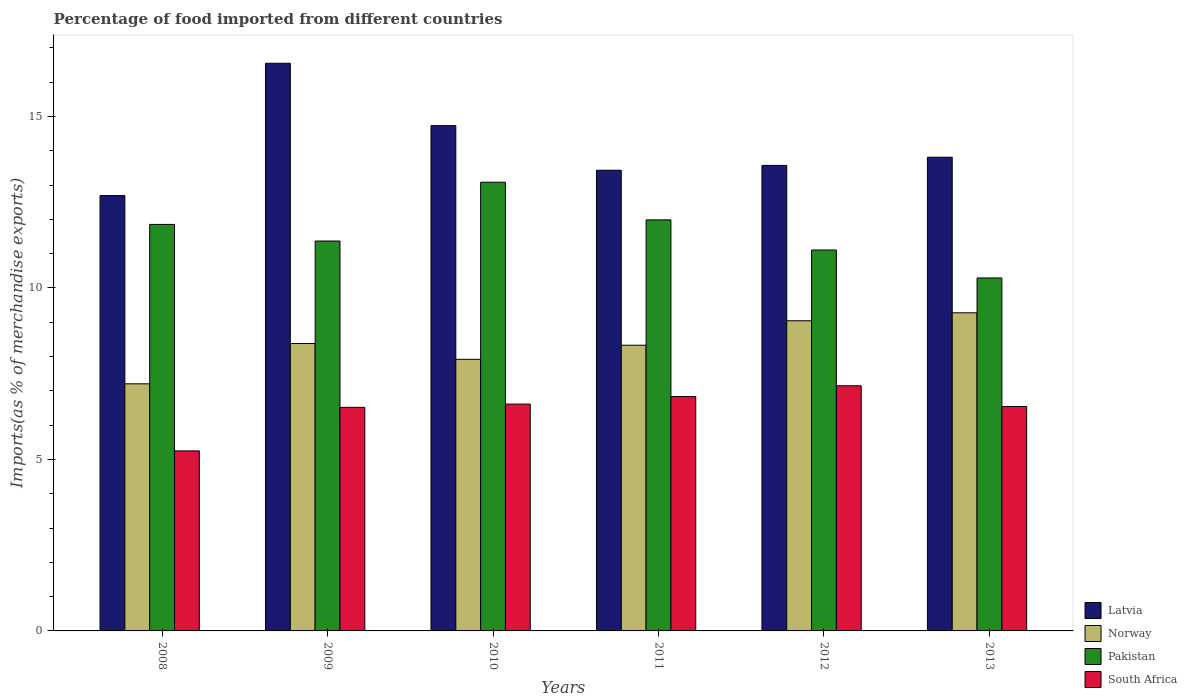How many different coloured bars are there?
Ensure brevity in your answer.  4. Are the number of bars per tick equal to the number of legend labels?
Your answer should be compact. Yes. How many bars are there on the 2nd tick from the left?
Provide a short and direct response. 4. How many bars are there on the 6th tick from the right?
Your response must be concise. 4. What is the label of the 2nd group of bars from the left?
Offer a terse response. 2009. What is the percentage of imports to different countries in Norway in 2008?
Your answer should be very brief. 7.21. Across all years, what is the maximum percentage of imports to different countries in Pakistan?
Provide a short and direct response. 13.08. Across all years, what is the minimum percentage of imports to different countries in Norway?
Offer a very short reply. 7.21. In which year was the percentage of imports to different countries in Norway minimum?
Offer a terse response. 2008. What is the total percentage of imports to different countries in South Africa in the graph?
Provide a succinct answer. 38.91. What is the difference between the percentage of imports to different countries in Pakistan in 2008 and that in 2013?
Your answer should be compact. 1.56. What is the difference between the percentage of imports to different countries in South Africa in 2010 and the percentage of imports to different countries in Norway in 2012?
Your answer should be very brief. -2.43. What is the average percentage of imports to different countries in Pakistan per year?
Make the answer very short. 11.62. In the year 2013, what is the difference between the percentage of imports to different countries in Pakistan and percentage of imports to different countries in Norway?
Your answer should be compact. 1.02. In how many years, is the percentage of imports to different countries in Norway greater than 1 %?
Your answer should be very brief. 6. What is the ratio of the percentage of imports to different countries in South Africa in 2011 to that in 2012?
Your answer should be very brief. 0.96. Is the difference between the percentage of imports to different countries in Pakistan in 2009 and 2011 greater than the difference between the percentage of imports to different countries in Norway in 2009 and 2011?
Your answer should be compact. No. What is the difference between the highest and the second highest percentage of imports to different countries in Latvia?
Keep it short and to the point. 1.82. What is the difference between the highest and the lowest percentage of imports to different countries in Norway?
Your answer should be compact. 2.07. Is it the case that in every year, the sum of the percentage of imports to different countries in Norway and percentage of imports to different countries in Pakistan is greater than the sum of percentage of imports to different countries in Latvia and percentage of imports to different countries in South Africa?
Make the answer very short. Yes. What does the 4th bar from the left in 2012 represents?
Keep it short and to the point. South Africa. What does the 1st bar from the right in 2011 represents?
Provide a short and direct response. South Africa. Is it the case that in every year, the sum of the percentage of imports to different countries in South Africa and percentage of imports to different countries in Latvia is greater than the percentage of imports to different countries in Pakistan?
Your answer should be compact. Yes. How many years are there in the graph?
Ensure brevity in your answer.  6. What is the difference between two consecutive major ticks on the Y-axis?
Offer a very short reply. 5. Does the graph contain any zero values?
Your answer should be very brief. No. How are the legend labels stacked?
Make the answer very short. Vertical. What is the title of the graph?
Your answer should be very brief. Percentage of food imported from different countries. What is the label or title of the X-axis?
Your response must be concise. Years. What is the label or title of the Y-axis?
Provide a short and direct response. Imports(as % of merchandise exports). What is the Imports(as % of merchandise exports) of Latvia in 2008?
Give a very brief answer. 12.69. What is the Imports(as % of merchandise exports) of Norway in 2008?
Your answer should be compact. 7.21. What is the Imports(as % of merchandise exports) in Pakistan in 2008?
Provide a succinct answer. 11.85. What is the Imports(as % of merchandise exports) of South Africa in 2008?
Provide a short and direct response. 5.25. What is the Imports(as % of merchandise exports) in Latvia in 2009?
Your answer should be compact. 16.55. What is the Imports(as % of merchandise exports) of Norway in 2009?
Offer a very short reply. 8.38. What is the Imports(as % of merchandise exports) in Pakistan in 2009?
Give a very brief answer. 11.37. What is the Imports(as % of merchandise exports) of South Africa in 2009?
Provide a short and direct response. 6.52. What is the Imports(as % of merchandise exports) of Latvia in 2010?
Your answer should be compact. 14.73. What is the Imports(as % of merchandise exports) of Norway in 2010?
Give a very brief answer. 7.92. What is the Imports(as % of merchandise exports) of Pakistan in 2010?
Offer a very short reply. 13.08. What is the Imports(as % of merchandise exports) of South Africa in 2010?
Offer a very short reply. 6.61. What is the Imports(as % of merchandise exports) of Latvia in 2011?
Make the answer very short. 13.43. What is the Imports(as % of merchandise exports) of Norway in 2011?
Your answer should be compact. 8.33. What is the Imports(as % of merchandise exports) of Pakistan in 2011?
Give a very brief answer. 11.99. What is the Imports(as % of merchandise exports) of South Africa in 2011?
Your answer should be very brief. 6.83. What is the Imports(as % of merchandise exports) in Latvia in 2012?
Your answer should be very brief. 13.57. What is the Imports(as % of merchandise exports) of Norway in 2012?
Your answer should be compact. 9.04. What is the Imports(as % of merchandise exports) of Pakistan in 2012?
Make the answer very short. 11.11. What is the Imports(as % of merchandise exports) of South Africa in 2012?
Offer a very short reply. 7.15. What is the Imports(as % of merchandise exports) of Latvia in 2013?
Provide a short and direct response. 13.81. What is the Imports(as % of merchandise exports) in Norway in 2013?
Provide a short and direct response. 9.28. What is the Imports(as % of merchandise exports) in Pakistan in 2013?
Keep it short and to the point. 10.29. What is the Imports(as % of merchandise exports) in South Africa in 2013?
Provide a succinct answer. 6.54. Across all years, what is the maximum Imports(as % of merchandise exports) in Latvia?
Provide a succinct answer. 16.55. Across all years, what is the maximum Imports(as % of merchandise exports) in Norway?
Offer a very short reply. 9.28. Across all years, what is the maximum Imports(as % of merchandise exports) in Pakistan?
Your response must be concise. 13.08. Across all years, what is the maximum Imports(as % of merchandise exports) of South Africa?
Your answer should be compact. 7.15. Across all years, what is the minimum Imports(as % of merchandise exports) of Latvia?
Give a very brief answer. 12.69. Across all years, what is the minimum Imports(as % of merchandise exports) in Norway?
Your response must be concise. 7.21. Across all years, what is the minimum Imports(as % of merchandise exports) of Pakistan?
Offer a terse response. 10.29. Across all years, what is the minimum Imports(as % of merchandise exports) of South Africa?
Keep it short and to the point. 5.25. What is the total Imports(as % of merchandise exports) of Latvia in the graph?
Your answer should be very brief. 84.8. What is the total Imports(as % of merchandise exports) of Norway in the graph?
Keep it short and to the point. 50.16. What is the total Imports(as % of merchandise exports) of Pakistan in the graph?
Keep it short and to the point. 69.69. What is the total Imports(as % of merchandise exports) in South Africa in the graph?
Ensure brevity in your answer.  38.91. What is the difference between the Imports(as % of merchandise exports) in Latvia in 2008 and that in 2009?
Make the answer very short. -3.86. What is the difference between the Imports(as % of merchandise exports) of Norway in 2008 and that in 2009?
Provide a succinct answer. -1.18. What is the difference between the Imports(as % of merchandise exports) of Pakistan in 2008 and that in 2009?
Ensure brevity in your answer.  0.48. What is the difference between the Imports(as % of merchandise exports) in South Africa in 2008 and that in 2009?
Offer a very short reply. -1.27. What is the difference between the Imports(as % of merchandise exports) in Latvia in 2008 and that in 2010?
Your answer should be very brief. -2.04. What is the difference between the Imports(as % of merchandise exports) of Norway in 2008 and that in 2010?
Keep it short and to the point. -0.71. What is the difference between the Imports(as % of merchandise exports) in Pakistan in 2008 and that in 2010?
Make the answer very short. -1.23. What is the difference between the Imports(as % of merchandise exports) of South Africa in 2008 and that in 2010?
Your response must be concise. -1.36. What is the difference between the Imports(as % of merchandise exports) in Latvia in 2008 and that in 2011?
Provide a succinct answer. -0.74. What is the difference between the Imports(as % of merchandise exports) of Norway in 2008 and that in 2011?
Ensure brevity in your answer.  -1.13. What is the difference between the Imports(as % of merchandise exports) of Pakistan in 2008 and that in 2011?
Your answer should be very brief. -0.13. What is the difference between the Imports(as % of merchandise exports) of South Africa in 2008 and that in 2011?
Your answer should be very brief. -1.58. What is the difference between the Imports(as % of merchandise exports) of Latvia in 2008 and that in 2012?
Offer a terse response. -0.88. What is the difference between the Imports(as % of merchandise exports) of Norway in 2008 and that in 2012?
Give a very brief answer. -1.84. What is the difference between the Imports(as % of merchandise exports) of Pakistan in 2008 and that in 2012?
Provide a succinct answer. 0.75. What is the difference between the Imports(as % of merchandise exports) in South Africa in 2008 and that in 2012?
Provide a succinct answer. -1.9. What is the difference between the Imports(as % of merchandise exports) in Latvia in 2008 and that in 2013?
Offer a terse response. -1.12. What is the difference between the Imports(as % of merchandise exports) in Norway in 2008 and that in 2013?
Keep it short and to the point. -2.07. What is the difference between the Imports(as % of merchandise exports) of Pakistan in 2008 and that in 2013?
Offer a terse response. 1.56. What is the difference between the Imports(as % of merchandise exports) of South Africa in 2008 and that in 2013?
Ensure brevity in your answer.  -1.29. What is the difference between the Imports(as % of merchandise exports) in Latvia in 2009 and that in 2010?
Ensure brevity in your answer.  1.82. What is the difference between the Imports(as % of merchandise exports) in Norway in 2009 and that in 2010?
Ensure brevity in your answer.  0.46. What is the difference between the Imports(as % of merchandise exports) in Pakistan in 2009 and that in 2010?
Your answer should be very brief. -1.71. What is the difference between the Imports(as % of merchandise exports) of South Africa in 2009 and that in 2010?
Your response must be concise. -0.1. What is the difference between the Imports(as % of merchandise exports) in Latvia in 2009 and that in 2011?
Your answer should be compact. 3.12. What is the difference between the Imports(as % of merchandise exports) in Norway in 2009 and that in 2011?
Your answer should be very brief. 0.05. What is the difference between the Imports(as % of merchandise exports) in Pakistan in 2009 and that in 2011?
Your answer should be compact. -0.62. What is the difference between the Imports(as % of merchandise exports) in South Africa in 2009 and that in 2011?
Ensure brevity in your answer.  -0.32. What is the difference between the Imports(as % of merchandise exports) of Latvia in 2009 and that in 2012?
Your answer should be very brief. 2.98. What is the difference between the Imports(as % of merchandise exports) in Norway in 2009 and that in 2012?
Your answer should be compact. -0.66. What is the difference between the Imports(as % of merchandise exports) in Pakistan in 2009 and that in 2012?
Keep it short and to the point. 0.26. What is the difference between the Imports(as % of merchandise exports) in South Africa in 2009 and that in 2012?
Offer a terse response. -0.63. What is the difference between the Imports(as % of merchandise exports) of Latvia in 2009 and that in 2013?
Your response must be concise. 2.74. What is the difference between the Imports(as % of merchandise exports) in Norway in 2009 and that in 2013?
Your answer should be very brief. -0.9. What is the difference between the Imports(as % of merchandise exports) of Pakistan in 2009 and that in 2013?
Keep it short and to the point. 1.08. What is the difference between the Imports(as % of merchandise exports) in South Africa in 2009 and that in 2013?
Provide a succinct answer. -0.02. What is the difference between the Imports(as % of merchandise exports) of Latvia in 2010 and that in 2011?
Give a very brief answer. 1.3. What is the difference between the Imports(as % of merchandise exports) of Norway in 2010 and that in 2011?
Your answer should be very brief. -0.41. What is the difference between the Imports(as % of merchandise exports) in Pakistan in 2010 and that in 2011?
Offer a terse response. 1.1. What is the difference between the Imports(as % of merchandise exports) in South Africa in 2010 and that in 2011?
Provide a succinct answer. -0.22. What is the difference between the Imports(as % of merchandise exports) of Latvia in 2010 and that in 2012?
Make the answer very short. 1.16. What is the difference between the Imports(as % of merchandise exports) of Norway in 2010 and that in 2012?
Make the answer very short. -1.12. What is the difference between the Imports(as % of merchandise exports) in Pakistan in 2010 and that in 2012?
Keep it short and to the point. 1.98. What is the difference between the Imports(as % of merchandise exports) of South Africa in 2010 and that in 2012?
Give a very brief answer. -0.53. What is the difference between the Imports(as % of merchandise exports) in Latvia in 2010 and that in 2013?
Your answer should be compact. 0.92. What is the difference between the Imports(as % of merchandise exports) of Norway in 2010 and that in 2013?
Ensure brevity in your answer.  -1.36. What is the difference between the Imports(as % of merchandise exports) of Pakistan in 2010 and that in 2013?
Offer a terse response. 2.79. What is the difference between the Imports(as % of merchandise exports) in South Africa in 2010 and that in 2013?
Provide a succinct answer. 0.07. What is the difference between the Imports(as % of merchandise exports) in Latvia in 2011 and that in 2012?
Your answer should be very brief. -0.14. What is the difference between the Imports(as % of merchandise exports) of Norway in 2011 and that in 2012?
Keep it short and to the point. -0.71. What is the difference between the Imports(as % of merchandise exports) in Pakistan in 2011 and that in 2012?
Offer a very short reply. 0.88. What is the difference between the Imports(as % of merchandise exports) of South Africa in 2011 and that in 2012?
Make the answer very short. -0.31. What is the difference between the Imports(as % of merchandise exports) in Latvia in 2011 and that in 2013?
Provide a short and direct response. -0.38. What is the difference between the Imports(as % of merchandise exports) of Norway in 2011 and that in 2013?
Your response must be concise. -0.95. What is the difference between the Imports(as % of merchandise exports) in Pakistan in 2011 and that in 2013?
Keep it short and to the point. 1.69. What is the difference between the Imports(as % of merchandise exports) in South Africa in 2011 and that in 2013?
Give a very brief answer. 0.29. What is the difference between the Imports(as % of merchandise exports) in Latvia in 2012 and that in 2013?
Offer a very short reply. -0.24. What is the difference between the Imports(as % of merchandise exports) in Norway in 2012 and that in 2013?
Your answer should be compact. -0.23. What is the difference between the Imports(as % of merchandise exports) in Pakistan in 2012 and that in 2013?
Keep it short and to the point. 0.82. What is the difference between the Imports(as % of merchandise exports) in South Africa in 2012 and that in 2013?
Provide a short and direct response. 0.6. What is the difference between the Imports(as % of merchandise exports) of Latvia in 2008 and the Imports(as % of merchandise exports) of Norway in 2009?
Provide a succinct answer. 4.31. What is the difference between the Imports(as % of merchandise exports) in Latvia in 2008 and the Imports(as % of merchandise exports) in Pakistan in 2009?
Make the answer very short. 1.32. What is the difference between the Imports(as % of merchandise exports) of Latvia in 2008 and the Imports(as % of merchandise exports) of South Africa in 2009?
Offer a very short reply. 6.18. What is the difference between the Imports(as % of merchandise exports) in Norway in 2008 and the Imports(as % of merchandise exports) in Pakistan in 2009?
Provide a short and direct response. -4.16. What is the difference between the Imports(as % of merchandise exports) of Norway in 2008 and the Imports(as % of merchandise exports) of South Africa in 2009?
Your response must be concise. 0.69. What is the difference between the Imports(as % of merchandise exports) in Pakistan in 2008 and the Imports(as % of merchandise exports) in South Africa in 2009?
Offer a very short reply. 5.33. What is the difference between the Imports(as % of merchandise exports) of Latvia in 2008 and the Imports(as % of merchandise exports) of Norway in 2010?
Your response must be concise. 4.77. What is the difference between the Imports(as % of merchandise exports) in Latvia in 2008 and the Imports(as % of merchandise exports) in Pakistan in 2010?
Offer a very short reply. -0.39. What is the difference between the Imports(as % of merchandise exports) in Latvia in 2008 and the Imports(as % of merchandise exports) in South Africa in 2010?
Your answer should be compact. 6.08. What is the difference between the Imports(as % of merchandise exports) in Norway in 2008 and the Imports(as % of merchandise exports) in Pakistan in 2010?
Offer a very short reply. -5.88. What is the difference between the Imports(as % of merchandise exports) in Norway in 2008 and the Imports(as % of merchandise exports) in South Africa in 2010?
Ensure brevity in your answer.  0.59. What is the difference between the Imports(as % of merchandise exports) of Pakistan in 2008 and the Imports(as % of merchandise exports) of South Africa in 2010?
Offer a terse response. 5.24. What is the difference between the Imports(as % of merchandise exports) in Latvia in 2008 and the Imports(as % of merchandise exports) in Norway in 2011?
Offer a terse response. 4.36. What is the difference between the Imports(as % of merchandise exports) in Latvia in 2008 and the Imports(as % of merchandise exports) in Pakistan in 2011?
Your response must be concise. 0.71. What is the difference between the Imports(as % of merchandise exports) of Latvia in 2008 and the Imports(as % of merchandise exports) of South Africa in 2011?
Provide a short and direct response. 5.86. What is the difference between the Imports(as % of merchandise exports) of Norway in 2008 and the Imports(as % of merchandise exports) of Pakistan in 2011?
Offer a very short reply. -4.78. What is the difference between the Imports(as % of merchandise exports) in Norway in 2008 and the Imports(as % of merchandise exports) in South Africa in 2011?
Your response must be concise. 0.37. What is the difference between the Imports(as % of merchandise exports) in Pakistan in 2008 and the Imports(as % of merchandise exports) in South Africa in 2011?
Your answer should be very brief. 5.02. What is the difference between the Imports(as % of merchandise exports) of Latvia in 2008 and the Imports(as % of merchandise exports) of Norway in 2012?
Make the answer very short. 3.65. What is the difference between the Imports(as % of merchandise exports) of Latvia in 2008 and the Imports(as % of merchandise exports) of Pakistan in 2012?
Ensure brevity in your answer.  1.59. What is the difference between the Imports(as % of merchandise exports) in Latvia in 2008 and the Imports(as % of merchandise exports) in South Africa in 2012?
Provide a short and direct response. 5.55. What is the difference between the Imports(as % of merchandise exports) of Norway in 2008 and the Imports(as % of merchandise exports) of Pakistan in 2012?
Offer a very short reply. -3.9. What is the difference between the Imports(as % of merchandise exports) in Norway in 2008 and the Imports(as % of merchandise exports) in South Africa in 2012?
Your answer should be very brief. 0.06. What is the difference between the Imports(as % of merchandise exports) of Pakistan in 2008 and the Imports(as % of merchandise exports) of South Africa in 2012?
Make the answer very short. 4.71. What is the difference between the Imports(as % of merchandise exports) of Latvia in 2008 and the Imports(as % of merchandise exports) of Norway in 2013?
Your answer should be compact. 3.42. What is the difference between the Imports(as % of merchandise exports) in Latvia in 2008 and the Imports(as % of merchandise exports) in Pakistan in 2013?
Your answer should be compact. 2.4. What is the difference between the Imports(as % of merchandise exports) in Latvia in 2008 and the Imports(as % of merchandise exports) in South Africa in 2013?
Keep it short and to the point. 6.15. What is the difference between the Imports(as % of merchandise exports) of Norway in 2008 and the Imports(as % of merchandise exports) of Pakistan in 2013?
Ensure brevity in your answer.  -3.09. What is the difference between the Imports(as % of merchandise exports) of Norway in 2008 and the Imports(as % of merchandise exports) of South Africa in 2013?
Ensure brevity in your answer.  0.66. What is the difference between the Imports(as % of merchandise exports) in Pakistan in 2008 and the Imports(as % of merchandise exports) in South Africa in 2013?
Provide a succinct answer. 5.31. What is the difference between the Imports(as % of merchandise exports) of Latvia in 2009 and the Imports(as % of merchandise exports) of Norway in 2010?
Your answer should be compact. 8.63. What is the difference between the Imports(as % of merchandise exports) in Latvia in 2009 and the Imports(as % of merchandise exports) in Pakistan in 2010?
Give a very brief answer. 3.47. What is the difference between the Imports(as % of merchandise exports) of Latvia in 2009 and the Imports(as % of merchandise exports) of South Africa in 2010?
Give a very brief answer. 9.94. What is the difference between the Imports(as % of merchandise exports) in Norway in 2009 and the Imports(as % of merchandise exports) in Pakistan in 2010?
Provide a short and direct response. -4.7. What is the difference between the Imports(as % of merchandise exports) of Norway in 2009 and the Imports(as % of merchandise exports) of South Africa in 2010?
Provide a short and direct response. 1.77. What is the difference between the Imports(as % of merchandise exports) of Pakistan in 2009 and the Imports(as % of merchandise exports) of South Africa in 2010?
Your answer should be compact. 4.75. What is the difference between the Imports(as % of merchandise exports) in Latvia in 2009 and the Imports(as % of merchandise exports) in Norway in 2011?
Provide a succinct answer. 8.22. What is the difference between the Imports(as % of merchandise exports) in Latvia in 2009 and the Imports(as % of merchandise exports) in Pakistan in 2011?
Offer a terse response. 4.57. What is the difference between the Imports(as % of merchandise exports) of Latvia in 2009 and the Imports(as % of merchandise exports) of South Africa in 2011?
Provide a succinct answer. 9.72. What is the difference between the Imports(as % of merchandise exports) in Norway in 2009 and the Imports(as % of merchandise exports) in Pakistan in 2011?
Keep it short and to the point. -3.61. What is the difference between the Imports(as % of merchandise exports) in Norway in 2009 and the Imports(as % of merchandise exports) in South Africa in 2011?
Provide a short and direct response. 1.55. What is the difference between the Imports(as % of merchandise exports) in Pakistan in 2009 and the Imports(as % of merchandise exports) in South Africa in 2011?
Ensure brevity in your answer.  4.54. What is the difference between the Imports(as % of merchandise exports) in Latvia in 2009 and the Imports(as % of merchandise exports) in Norway in 2012?
Provide a succinct answer. 7.51. What is the difference between the Imports(as % of merchandise exports) of Latvia in 2009 and the Imports(as % of merchandise exports) of Pakistan in 2012?
Make the answer very short. 5.45. What is the difference between the Imports(as % of merchandise exports) in Latvia in 2009 and the Imports(as % of merchandise exports) in South Africa in 2012?
Provide a short and direct response. 9.4. What is the difference between the Imports(as % of merchandise exports) in Norway in 2009 and the Imports(as % of merchandise exports) in Pakistan in 2012?
Your answer should be very brief. -2.73. What is the difference between the Imports(as % of merchandise exports) of Norway in 2009 and the Imports(as % of merchandise exports) of South Africa in 2012?
Keep it short and to the point. 1.23. What is the difference between the Imports(as % of merchandise exports) of Pakistan in 2009 and the Imports(as % of merchandise exports) of South Africa in 2012?
Offer a terse response. 4.22. What is the difference between the Imports(as % of merchandise exports) of Latvia in 2009 and the Imports(as % of merchandise exports) of Norway in 2013?
Ensure brevity in your answer.  7.28. What is the difference between the Imports(as % of merchandise exports) of Latvia in 2009 and the Imports(as % of merchandise exports) of Pakistan in 2013?
Provide a short and direct response. 6.26. What is the difference between the Imports(as % of merchandise exports) of Latvia in 2009 and the Imports(as % of merchandise exports) of South Africa in 2013?
Give a very brief answer. 10.01. What is the difference between the Imports(as % of merchandise exports) in Norway in 2009 and the Imports(as % of merchandise exports) in Pakistan in 2013?
Offer a terse response. -1.91. What is the difference between the Imports(as % of merchandise exports) of Norway in 2009 and the Imports(as % of merchandise exports) of South Africa in 2013?
Your answer should be compact. 1.84. What is the difference between the Imports(as % of merchandise exports) in Pakistan in 2009 and the Imports(as % of merchandise exports) in South Africa in 2013?
Provide a succinct answer. 4.83. What is the difference between the Imports(as % of merchandise exports) in Latvia in 2010 and the Imports(as % of merchandise exports) in Norway in 2011?
Your answer should be compact. 6.4. What is the difference between the Imports(as % of merchandise exports) of Latvia in 2010 and the Imports(as % of merchandise exports) of Pakistan in 2011?
Give a very brief answer. 2.75. What is the difference between the Imports(as % of merchandise exports) in Latvia in 2010 and the Imports(as % of merchandise exports) in South Africa in 2011?
Your response must be concise. 7.9. What is the difference between the Imports(as % of merchandise exports) in Norway in 2010 and the Imports(as % of merchandise exports) in Pakistan in 2011?
Ensure brevity in your answer.  -4.07. What is the difference between the Imports(as % of merchandise exports) of Norway in 2010 and the Imports(as % of merchandise exports) of South Africa in 2011?
Provide a succinct answer. 1.09. What is the difference between the Imports(as % of merchandise exports) of Pakistan in 2010 and the Imports(as % of merchandise exports) of South Africa in 2011?
Keep it short and to the point. 6.25. What is the difference between the Imports(as % of merchandise exports) in Latvia in 2010 and the Imports(as % of merchandise exports) in Norway in 2012?
Provide a short and direct response. 5.69. What is the difference between the Imports(as % of merchandise exports) in Latvia in 2010 and the Imports(as % of merchandise exports) in Pakistan in 2012?
Keep it short and to the point. 3.63. What is the difference between the Imports(as % of merchandise exports) in Latvia in 2010 and the Imports(as % of merchandise exports) in South Africa in 2012?
Your answer should be very brief. 7.59. What is the difference between the Imports(as % of merchandise exports) in Norway in 2010 and the Imports(as % of merchandise exports) in Pakistan in 2012?
Provide a succinct answer. -3.19. What is the difference between the Imports(as % of merchandise exports) of Norway in 2010 and the Imports(as % of merchandise exports) of South Africa in 2012?
Provide a short and direct response. 0.77. What is the difference between the Imports(as % of merchandise exports) in Pakistan in 2010 and the Imports(as % of merchandise exports) in South Africa in 2012?
Keep it short and to the point. 5.94. What is the difference between the Imports(as % of merchandise exports) of Latvia in 2010 and the Imports(as % of merchandise exports) of Norway in 2013?
Your answer should be very brief. 5.46. What is the difference between the Imports(as % of merchandise exports) of Latvia in 2010 and the Imports(as % of merchandise exports) of Pakistan in 2013?
Your response must be concise. 4.44. What is the difference between the Imports(as % of merchandise exports) in Latvia in 2010 and the Imports(as % of merchandise exports) in South Africa in 2013?
Your answer should be very brief. 8.19. What is the difference between the Imports(as % of merchandise exports) in Norway in 2010 and the Imports(as % of merchandise exports) in Pakistan in 2013?
Ensure brevity in your answer.  -2.37. What is the difference between the Imports(as % of merchandise exports) of Norway in 2010 and the Imports(as % of merchandise exports) of South Africa in 2013?
Keep it short and to the point. 1.38. What is the difference between the Imports(as % of merchandise exports) of Pakistan in 2010 and the Imports(as % of merchandise exports) of South Africa in 2013?
Your answer should be very brief. 6.54. What is the difference between the Imports(as % of merchandise exports) of Latvia in 2011 and the Imports(as % of merchandise exports) of Norway in 2012?
Provide a succinct answer. 4.39. What is the difference between the Imports(as % of merchandise exports) in Latvia in 2011 and the Imports(as % of merchandise exports) in Pakistan in 2012?
Your answer should be very brief. 2.33. What is the difference between the Imports(as % of merchandise exports) of Latvia in 2011 and the Imports(as % of merchandise exports) of South Africa in 2012?
Offer a very short reply. 6.29. What is the difference between the Imports(as % of merchandise exports) of Norway in 2011 and the Imports(as % of merchandise exports) of Pakistan in 2012?
Make the answer very short. -2.78. What is the difference between the Imports(as % of merchandise exports) of Norway in 2011 and the Imports(as % of merchandise exports) of South Africa in 2012?
Offer a terse response. 1.18. What is the difference between the Imports(as % of merchandise exports) in Pakistan in 2011 and the Imports(as % of merchandise exports) in South Africa in 2012?
Your answer should be very brief. 4.84. What is the difference between the Imports(as % of merchandise exports) of Latvia in 2011 and the Imports(as % of merchandise exports) of Norway in 2013?
Your answer should be very brief. 4.16. What is the difference between the Imports(as % of merchandise exports) in Latvia in 2011 and the Imports(as % of merchandise exports) in Pakistan in 2013?
Make the answer very short. 3.14. What is the difference between the Imports(as % of merchandise exports) of Latvia in 2011 and the Imports(as % of merchandise exports) of South Africa in 2013?
Keep it short and to the point. 6.89. What is the difference between the Imports(as % of merchandise exports) in Norway in 2011 and the Imports(as % of merchandise exports) in Pakistan in 2013?
Provide a succinct answer. -1.96. What is the difference between the Imports(as % of merchandise exports) of Norway in 2011 and the Imports(as % of merchandise exports) of South Africa in 2013?
Offer a very short reply. 1.79. What is the difference between the Imports(as % of merchandise exports) of Pakistan in 2011 and the Imports(as % of merchandise exports) of South Africa in 2013?
Provide a succinct answer. 5.44. What is the difference between the Imports(as % of merchandise exports) in Latvia in 2012 and the Imports(as % of merchandise exports) in Norway in 2013?
Keep it short and to the point. 4.3. What is the difference between the Imports(as % of merchandise exports) in Latvia in 2012 and the Imports(as % of merchandise exports) in Pakistan in 2013?
Your answer should be very brief. 3.28. What is the difference between the Imports(as % of merchandise exports) in Latvia in 2012 and the Imports(as % of merchandise exports) in South Africa in 2013?
Provide a short and direct response. 7.03. What is the difference between the Imports(as % of merchandise exports) of Norway in 2012 and the Imports(as % of merchandise exports) of Pakistan in 2013?
Make the answer very short. -1.25. What is the difference between the Imports(as % of merchandise exports) in Norway in 2012 and the Imports(as % of merchandise exports) in South Africa in 2013?
Offer a very short reply. 2.5. What is the difference between the Imports(as % of merchandise exports) of Pakistan in 2012 and the Imports(as % of merchandise exports) of South Africa in 2013?
Keep it short and to the point. 4.56. What is the average Imports(as % of merchandise exports) of Latvia per year?
Provide a short and direct response. 14.13. What is the average Imports(as % of merchandise exports) of Norway per year?
Your answer should be very brief. 8.36. What is the average Imports(as % of merchandise exports) of Pakistan per year?
Offer a very short reply. 11.62. What is the average Imports(as % of merchandise exports) of South Africa per year?
Give a very brief answer. 6.49. In the year 2008, what is the difference between the Imports(as % of merchandise exports) in Latvia and Imports(as % of merchandise exports) in Norway?
Keep it short and to the point. 5.49. In the year 2008, what is the difference between the Imports(as % of merchandise exports) in Latvia and Imports(as % of merchandise exports) in Pakistan?
Keep it short and to the point. 0.84. In the year 2008, what is the difference between the Imports(as % of merchandise exports) of Latvia and Imports(as % of merchandise exports) of South Africa?
Offer a terse response. 7.44. In the year 2008, what is the difference between the Imports(as % of merchandise exports) in Norway and Imports(as % of merchandise exports) in Pakistan?
Give a very brief answer. -4.65. In the year 2008, what is the difference between the Imports(as % of merchandise exports) in Norway and Imports(as % of merchandise exports) in South Africa?
Make the answer very short. 1.96. In the year 2008, what is the difference between the Imports(as % of merchandise exports) of Pakistan and Imports(as % of merchandise exports) of South Africa?
Give a very brief answer. 6.6. In the year 2009, what is the difference between the Imports(as % of merchandise exports) of Latvia and Imports(as % of merchandise exports) of Norway?
Your answer should be very brief. 8.17. In the year 2009, what is the difference between the Imports(as % of merchandise exports) in Latvia and Imports(as % of merchandise exports) in Pakistan?
Provide a succinct answer. 5.18. In the year 2009, what is the difference between the Imports(as % of merchandise exports) of Latvia and Imports(as % of merchandise exports) of South Africa?
Give a very brief answer. 10.03. In the year 2009, what is the difference between the Imports(as % of merchandise exports) of Norway and Imports(as % of merchandise exports) of Pakistan?
Your answer should be very brief. -2.99. In the year 2009, what is the difference between the Imports(as % of merchandise exports) in Norway and Imports(as % of merchandise exports) in South Africa?
Give a very brief answer. 1.86. In the year 2009, what is the difference between the Imports(as % of merchandise exports) of Pakistan and Imports(as % of merchandise exports) of South Africa?
Ensure brevity in your answer.  4.85. In the year 2010, what is the difference between the Imports(as % of merchandise exports) of Latvia and Imports(as % of merchandise exports) of Norway?
Offer a very short reply. 6.81. In the year 2010, what is the difference between the Imports(as % of merchandise exports) of Latvia and Imports(as % of merchandise exports) of Pakistan?
Make the answer very short. 1.65. In the year 2010, what is the difference between the Imports(as % of merchandise exports) of Latvia and Imports(as % of merchandise exports) of South Africa?
Your answer should be compact. 8.12. In the year 2010, what is the difference between the Imports(as % of merchandise exports) of Norway and Imports(as % of merchandise exports) of Pakistan?
Offer a very short reply. -5.16. In the year 2010, what is the difference between the Imports(as % of merchandise exports) of Norway and Imports(as % of merchandise exports) of South Africa?
Your answer should be very brief. 1.31. In the year 2010, what is the difference between the Imports(as % of merchandise exports) in Pakistan and Imports(as % of merchandise exports) in South Africa?
Your response must be concise. 6.47. In the year 2011, what is the difference between the Imports(as % of merchandise exports) of Latvia and Imports(as % of merchandise exports) of Norway?
Your answer should be compact. 5.1. In the year 2011, what is the difference between the Imports(as % of merchandise exports) in Latvia and Imports(as % of merchandise exports) in Pakistan?
Give a very brief answer. 1.45. In the year 2011, what is the difference between the Imports(as % of merchandise exports) in Latvia and Imports(as % of merchandise exports) in South Africa?
Your response must be concise. 6.6. In the year 2011, what is the difference between the Imports(as % of merchandise exports) of Norway and Imports(as % of merchandise exports) of Pakistan?
Your response must be concise. -3.66. In the year 2011, what is the difference between the Imports(as % of merchandise exports) of Norway and Imports(as % of merchandise exports) of South Africa?
Make the answer very short. 1.5. In the year 2011, what is the difference between the Imports(as % of merchandise exports) in Pakistan and Imports(as % of merchandise exports) in South Africa?
Give a very brief answer. 5.15. In the year 2012, what is the difference between the Imports(as % of merchandise exports) in Latvia and Imports(as % of merchandise exports) in Norway?
Ensure brevity in your answer.  4.53. In the year 2012, what is the difference between the Imports(as % of merchandise exports) of Latvia and Imports(as % of merchandise exports) of Pakistan?
Your answer should be very brief. 2.47. In the year 2012, what is the difference between the Imports(as % of merchandise exports) of Latvia and Imports(as % of merchandise exports) of South Africa?
Keep it short and to the point. 6.43. In the year 2012, what is the difference between the Imports(as % of merchandise exports) in Norway and Imports(as % of merchandise exports) in Pakistan?
Your answer should be compact. -2.06. In the year 2012, what is the difference between the Imports(as % of merchandise exports) in Norway and Imports(as % of merchandise exports) in South Africa?
Your response must be concise. 1.9. In the year 2012, what is the difference between the Imports(as % of merchandise exports) in Pakistan and Imports(as % of merchandise exports) in South Africa?
Provide a succinct answer. 3.96. In the year 2013, what is the difference between the Imports(as % of merchandise exports) of Latvia and Imports(as % of merchandise exports) of Norway?
Offer a very short reply. 4.54. In the year 2013, what is the difference between the Imports(as % of merchandise exports) in Latvia and Imports(as % of merchandise exports) in Pakistan?
Your answer should be compact. 3.52. In the year 2013, what is the difference between the Imports(as % of merchandise exports) in Latvia and Imports(as % of merchandise exports) in South Africa?
Offer a terse response. 7.27. In the year 2013, what is the difference between the Imports(as % of merchandise exports) in Norway and Imports(as % of merchandise exports) in Pakistan?
Offer a very short reply. -1.02. In the year 2013, what is the difference between the Imports(as % of merchandise exports) in Norway and Imports(as % of merchandise exports) in South Africa?
Your response must be concise. 2.73. In the year 2013, what is the difference between the Imports(as % of merchandise exports) of Pakistan and Imports(as % of merchandise exports) of South Africa?
Your response must be concise. 3.75. What is the ratio of the Imports(as % of merchandise exports) in Latvia in 2008 to that in 2009?
Provide a short and direct response. 0.77. What is the ratio of the Imports(as % of merchandise exports) in Norway in 2008 to that in 2009?
Ensure brevity in your answer.  0.86. What is the ratio of the Imports(as % of merchandise exports) in Pakistan in 2008 to that in 2009?
Offer a very short reply. 1.04. What is the ratio of the Imports(as % of merchandise exports) in South Africa in 2008 to that in 2009?
Your answer should be very brief. 0.81. What is the ratio of the Imports(as % of merchandise exports) of Latvia in 2008 to that in 2010?
Make the answer very short. 0.86. What is the ratio of the Imports(as % of merchandise exports) of Norway in 2008 to that in 2010?
Offer a terse response. 0.91. What is the ratio of the Imports(as % of merchandise exports) of Pakistan in 2008 to that in 2010?
Your answer should be compact. 0.91. What is the ratio of the Imports(as % of merchandise exports) in South Africa in 2008 to that in 2010?
Your answer should be very brief. 0.79. What is the ratio of the Imports(as % of merchandise exports) of Latvia in 2008 to that in 2011?
Provide a short and direct response. 0.94. What is the ratio of the Imports(as % of merchandise exports) of Norway in 2008 to that in 2011?
Make the answer very short. 0.86. What is the ratio of the Imports(as % of merchandise exports) of South Africa in 2008 to that in 2011?
Your answer should be very brief. 0.77. What is the ratio of the Imports(as % of merchandise exports) of Latvia in 2008 to that in 2012?
Your answer should be very brief. 0.94. What is the ratio of the Imports(as % of merchandise exports) in Norway in 2008 to that in 2012?
Ensure brevity in your answer.  0.8. What is the ratio of the Imports(as % of merchandise exports) in Pakistan in 2008 to that in 2012?
Provide a succinct answer. 1.07. What is the ratio of the Imports(as % of merchandise exports) in South Africa in 2008 to that in 2012?
Your answer should be very brief. 0.73. What is the ratio of the Imports(as % of merchandise exports) of Latvia in 2008 to that in 2013?
Ensure brevity in your answer.  0.92. What is the ratio of the Imports(as % of merchandise exports) in Norway in 2008 to that in 2013?
Keep it short and to the point. 0.78. What is the ratio of the Imports(as % of merchandise exports) in Pakistan in 2008 to that in 2013?
Your answer should be compact. 1.15. What is the ratio of the Imports(as % of merchandise exports) of South Africa in 2008 to that in 2013?
Provide a succinct answer. 0.8. What is the ratio of the Imports(as % of merchandise exports) of Latvia in 2009 to that in 2010?
Offer a terse response. 1.12. What is the ratio of the Imports(as % of merchandise exports) in Norway in 2009 to that in 2010?
Offer a terse response. 1.06. What is the ratio of the Imports(as % of merchandise exports) of Pakistan in 2009 to that in 2010?
Offer a very short reply. 0.87. What is the ratio of the Imports(as % of merchandise exports) in South Africa in 2009 to that in 2010?
Your answer should be compact. 0.99. What is the ratio of the Imports(as % of merchandise exports) of Latvia in 2009 to that in 2011?
Keep it short and to the point. 1.23. What is the ratio of the Imports(as % of merchandise exports) of Pakistan in 2009 to that in 2011?
Provide a succinct answer. 0.95. What is the ratio of the Imports(as % of merchandise exports) of South Africa in 2009 to that in 2011?
Offer a very short reply. 0.95. What is the ratio of the Imports(as % of merchandise exports) in Latvia in 2009 to that in 2012?
Provide a succinct answer. 1.22. What is the ratio of the Imports(as % of merchandise exports) in Norway in 2009 to that in 2012?
Make the answer very short. 0.93. What is the ratio of the Imports(as % of merchandise exports) of Pakistan in 2009 to that in 2012?
Provide a succinct answer. 1.02. What is the ratio of the Imports(as % of merchandise exports) of South Africa in 2009 to that in 2012?
Offer a terse response. 0.91. What is the ratio of the Imports(as % of merchandise exports) of Latvia in 2009 to that in 2013?
Your answer should be very brief. 1.2. What is the ratio of the Imports(as % of merchandise exports) of Norway in 2009 to that in 2013?
Your answer should be compact. 0.9. What is the ratio of the Imports(as % of merchandise exports) in Pakistan in 2009 to that in 2013?
Give a very brief answer. 1.1. What is the ratio of the Imports(as % of merchandise exports) of South Africa in 2009 to that in 2013?
Provide a short and direct response. 1. What is the ratio of the Imports(as % of merchandise exports) of Latvia in 2010 to that in 2011?
Your response must be concise. 1.1. What is the ratio of the Imports(as % of merchandise exports) in Norway in 2010 to that in 2011?
Your answer should be very brief. 0.95. What is the ratio of the Imports(as % of merchandise exports) of Pakistan in 2010 to that in 2011?
Your answer should be very brief. 1.09. What is the ratio of the Imports(as % of merchandise exports) in South Africa in 2010 to that in 2011?
Your answer should be compact. 0.97. What is the ratio of the Imports(as % of merchandise exports) in Latvia in 2010 to that in 2012?
Provide a succinct answer. 1.09. What is the ratio of the Imports(as % of merchandise exports) of Norway in 2010 to that in 2012?
Your response must be concise. 0.88. What is the ratio of the Imports(as % of merchandise exports) of Pakistan in 2010 to that in 2012?
Give a very brief answer. 1.18. What is the ratio of the Imports(as % of merchandise exports) in South Africa in 2010 to that in 2012?
Offer a terse response. 0.93. What is the ratio of the Imports(as % of merchandise exports) in Latvia in 2010 to that in 2013?
Your response must be concise. 1.07. What is the ratio of the Imports(as % of merchandise exports) in Norway in 2010 to that in 2013?
Keep it short and to the point. 0.85. What is the ratio of the Imports(as % of merchandise exports) of Pakistan in 2010 to that in 2013?
Offer a very short reply. 1.27. What is the ratio of the Imports(as % of merchandise exports) of South Africa in 2010 to that in 2013?
Keep it short and to the point. 1.01. What is the ratio of the Imports(as % of merchandise exports) of Norway in 2011 to that in 2012?
Your answer should be very brief. 0.92. What is the ratio of the Imports(as % of merchandise exports) of Pakistan in 2011 to that in 2012?
Your answer should be compact. 1.08. What is the ratio of the Imports(as % of merchandise exports) of South Africa in 2011 to that in 2012?
Provide a succinct answer. 0.96. What is the ratio of the Imports(as % of merchandise exports) in Latvia in 2011 to that in 2013?
Make the answer very short. 0.97. What is the ratio of the Imports(as % of merchandise exports) of Norway in 2011 to that in 2013?
Your answer should be compact. 0.9. What is the ratio of the Imports(as % of merchandise exports) in Pakistan in 2011 to that in 2013?
Your answer should be very brief. 1.16. What is the ratio of the Imports(as % of merchandise exports) in South Africa in 2011 to that in 2013?
Offer a very short reply. 1.04. What is the ratio of the Imports(as % of merchandise exports) of Latvia in 2012 to that in 2013?
Your response must be concise. 0.98. What is the ratio of the Imports(as % of merchandise exports) of Norway in 2012 to that in 2013?
Provide a succinct answer. 0.97. What is the ratio of the Imports(as % of merchandise exports) of Pakistan in 2012 to that in 2013?
Ensure brevity in your answer.  1.08. What is the ratio of the Imports(as % of merchandise exports) of South Africa in 2012 to that in 2013?
Give a very brief answer. 1.09. What is the difference between the highest and the second highest Imports(as % of merchandise exports) of Latvia?
Provide a succinct answer. 1.82. What is the difference between the highest and the second highest Imports(as % of merchandise exports) of Norway?
Give a very brief answer. 0.23. What is the difference between the highest and the second highest Imports(as % of merchandise exports) of Pakistan?
Offer a very short reply. 1.1. What is the difference between the highest and the second highest Imports(as % of merchandise exports) of South Africa?
Provide a short and direct response. 0.31. What is the difference between the highest and the lowest Imports(as % of merchandise exports) in Latvia?
Provide a succinct answer. 3.86. What is the difference between the highest and the lowest Imports(as % of merchandise exports) of Norway?
Offer a very short reply. 2.07. What is the difference between the highest and the lowest Imports(as % of merchandise exports) of Pakistan?
Make the answer very short. 2.79. What is the difference between the highest and the lowest Imports(as % of merchandise exports) in South Africa?
Provide a short and direct response. 1.9. 